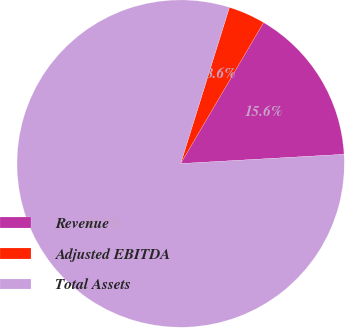Convert chart to OTSL. <chart><loc_0><loc_0><loc_500><loc_500><pie_chart><fcel>Revenue<fcel>Adjusted EBITDA<fcel>Total Assets<nl><fcel>15.64%<fcel>3.64%<fcel>80.72%<nl></chart> 